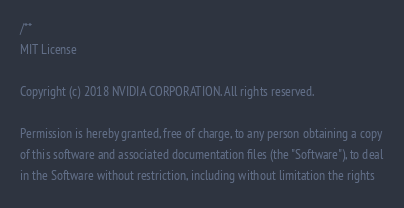Convert code to text. <code><loc_0><loc_0><loc_500><loc_500><_C++_>/**
MIT License

Copyright (c) 2018 NVIDIA CORPORATION. All rights reserved.

Permission is hereby granted, free of charge, to any person obtaining a copy
of this software and associated documentation files (the "Software"), to deal
in the Software without restriction, including without limitation the rights</code> 